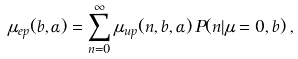Convert formula to latex. <formula><loc_0><loc_0><loc_500><loc_500>\mu _ { e p } ( b , \alpha ) = \sum _ { n = 0 } ^ { \infty } \mu _ { u p } ( n , b , \alpha ) \, P ( n | \mu = 0 , b ) \, ,</formula> 